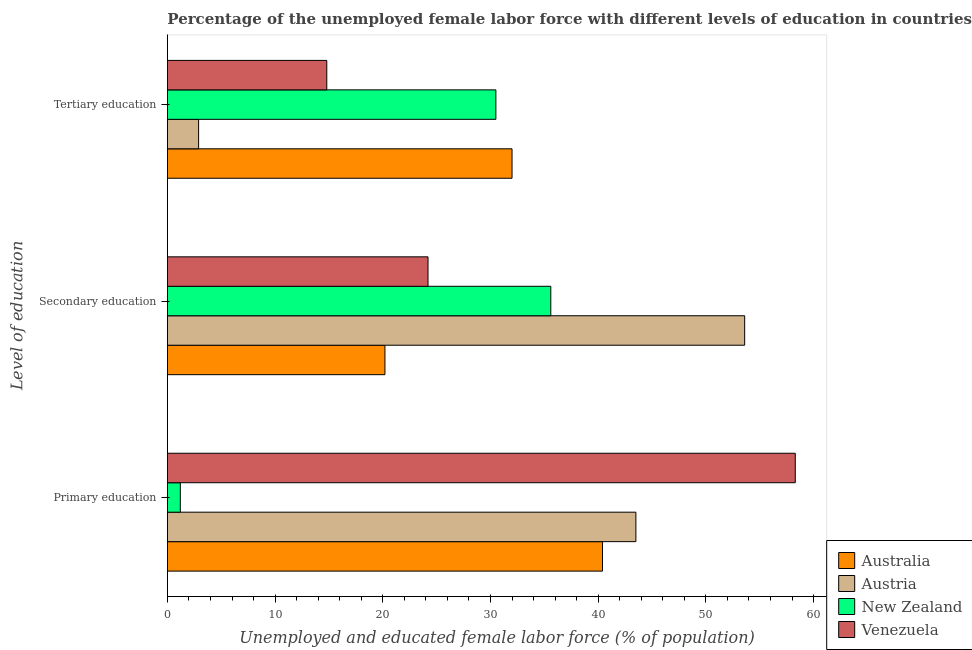How many bars are there on the 1st tick from the top?
Your answer should be very brief. 4. What is the percentage of female labor force who received tertiary education in Venezuela?
Your answer should be very brief. 14.8. Across all countries, what is the maximum percentage of female labor force who received tertiary education?
Ensure brevity in your answer.  32. Across all countries, what is the minimum percentage of female labor force who received primary education?
Offer a very short reply. 1.2. In which country was the percentage of female labor force who received primary education maximum?
Keep it short and to the point. Venezuela. In which country was the percentage of female labor force who received tertiary education minimum?
Your answer should be compact. Austria. What is the total percentage of female labor force who received primary education in the graph?
Give a very brief answer. 143.4. What is the difference between the percentage of female labor force who received tertiary education in Venezuela and that in Austria?
Provide a succinct answer. 11.9. What is the difference between the percentage of female labor force who received primary education in New Zealand and the percentage of female labor force who received tertiary education in Austria?
Make the answer very short. -1.7. What is the average percentage of female labor force who received primary education per country?
Provide a short and direct response. 35.85. What is the difference between the percentage of female labor force who received secondary education and percentage of female labor force who received tertiary education in New Zealand?
Your answer should be compact. 5.1. What is the ratio of the percentage of female labor force who received primary education in Australia to that in New Zealand?
Ensure brevity in your answer.  33.67. Is the difference between the percentage of female labor force who received tertiary education in Australia and New Zealand greater than the difference between the percentage of female labor force who received secondary education in Australia and New Zealand?
Your answer should be compact. Yes. What is the difference between the highest and the lowest percentage of female labor force who received secondary education?
Provide a succinct answer. 33.4. In how many countries, is the percentage of female labor force who received secondary education greater than the average percentage of female labor force who received secondary education taken over all countries?
Keep it short and to the point. 2. What does the 3rd bar from the top in Secondary education represents?
Ensure brevity in your answer.  Austria. What does the 3rd bar from the bottom in Tertiary education represents?
Ensure brevity in your answer.  New Zealand. How many countries are there in the graph?
Provide a succinct answer. 4. What is the difference between two consecutive major ticks on the X-axis?
Make the answer very short. 10. Are the values on the major ticks of X-axis written in scientific E-notation?
Provide a short and direct response. No. Does the graph contain any zero values?
Your answer should be very brief. No. Does the graph contain grids?
Your response must be concise. No. What is the title of the graph?
Offer a very short reply. Percentage of the unemployed female labor force with different levels of education in countries. What is the label or title of the X-axis?
Your answer should be compact. Unemployed and educated female labor force (% of population). What is the label or title of the Y-axis?
Your response must be concise. Level of education. What is the Unemployed and educated female labor force (% of population) in Australia in Primary education?
Give a very brief answer. 40.4. What is the Unemployed and educated female labor force (% of population) in Austria in Primary education?
Your response must be concise. 43.5. What is the Unemployed and educated female labor force (% of population) in New Zealand in Primary education?
Offer a very short reply. 1.2. What is the Unemployed and educated female labor force (% of population) of Venezuela in Primary education?
Keep it short and to the point. 58.3. What is the Unemployed and educated female labor force (% of population) of Australia in Secondary education?
Your answer should be very brief. 20.2. What is the Unemployed and educated female labor force (% of population) of Austria in Secondary education?
Offer a terse response. 53.6. What is the Unemployed and educated female labor force (% of population) of New Zealand in Secondary education?
Offer a very short reply. 35.6. What is the Unemployed and educated female labor force (% of population) of Venezuela in Secondary education?
Ensure brevity in your answer.  24.2. What is the Unemployed and educated female labor force (% of population) in Australia in Tertiary education?
Ensure brevity in your answer.  32. What is the Unemployed and educated female labor force (% of population) in Austria in Tertiary education?
Offer a terse response. 2.9. What is the Unemployed and educated female labor force (% of population) in New Zealand in Tertiary education?
Your response must be concise. 30.5. What is the Unemployed and educated female labor force (% of population) of Venezuela in Tertiary education?
Provide a short and direct response. 14.8. Across all Level of education, what is the maximum Unemployed and educated female labor force (% of population) of Australia?
Offer a terse response. 40.4. Across all Level of education, what is the maximum Unemployed and educated female labor force (% of population) in Austria?
Ensure brevity in your answer.  53.6. Across all Level of education, what is the maximum Unemployed and educated female labor force (% of population) in New Zealand?
Ensure brevity in your answer.  35.6. Across all Level of education, what is the maximum Unemployed and educated female labor force (% of population) in Venezuela?
Keep it short and to the point. 58.3. Across all Level of education, what is the minimum Unemployed and educated female labor force (% of population) of Australia?
Provide a short and direct response. 20.2. Across all Level of education, what is the minimum Unemployed and educated female labor force (% of population) of Austria?
Offer a terse response. 2.9. Across all Level of education, what is the minimum Unemployed and educated female labor force (% of population) in New Zealand?
Your answer should be very brief. 1.2. Across all Level of education, what is the minimum Unemployed and educated female labor force (% of population) in Venezuela?
Provide a short and direct response. 14.8. What is the total Unemployed and educated female labor force (% of population) in Australia in the graph?
Your response must be concise. 92.6. What is the total Unemployed and educated female labor force (% of population) of Austria in the graph?
Provide a succinct answer. 100. What is the total Unemployed and educated female labor force (% of population) in New Zealand in the graph?
Your response must be concise. 67.3. What is the total Unemployed and educated female labor force (% of population) in Venezuela in the graph?
Give a very brief answer. 97.3. What is the difference between the Unemployed and educated female labor force (% of population) of Australia in Primary education and that in Secondary education?
Your answer should be very brief. 20.2. What is the difference between the Unemployed and educated female labor force (% of population) in New Zealand in Primary education and that in Secondary education?
Make the answer very short. -34.4. What is the difference between the Unemployed and educated female labor force (% of population) of Venezuela in Primary education and that in Secondary education?
Keep it short and to the point. 34.1. What is the difference between the Unemployed and educated female labor force (% of population) in Austria in Primary education and that in Tertiary education?
Give a very brief answer. 40.6. What is the difference between the Unemployed and educated female labor force (% of population) of New Zealand in Primary education and that in Tertiary education?
Make the answer very short. -29.3. What is the difference between the Unemployed and educated female labor force (% of population) in Venezuela in Primary education and that in Tertiary education?
Offer a terse response. 43.5. What is the difference between the Unemployed and educated female labor force (% of population) of Australia in Secondary education and that in Tertiary education?
Make the answer very short. -11.8. What is the difference between the Unemployed and educated female labor force (% of population) in Austria in Secondary education and that in Tertiary education?
Provide a short and direct response. 50.7. What is the difference between the Unemployed and educated female labor force (% of population) in New Zealand in Secondary education and that in Tertiary education?
Ensure brevity in your answer.  5.1. What is the difference between the Unemployed and educated female labor force (% of population) of Venezuela in Secondary education and that in Tertiary education?
Your response must be concise. 9.4. What is the difference between the Unemployed and educated female labor force (% of population) in Australia in Primary education and the Unemployed and educated female labor force (% of population) in New Zealand in Secondary education?
Offer a terse response. 4.8. What is the difference between the Unemployed and educated female labor force (% of population) in Austria in Primary education and the Unemployed and educated female labor force (% of population) in New Zealand in Secondary education?
Make the answer very short. 7.9. What is the difference between the Unemployed and educated female labor force (% of population) in Austria in Primary education and the Unemployed and educated female labor force (% of population) in Venezuela in Secondary education?
Offer a very short reply. 19.3. What is the difference between the Unemployed and educated female labor force (% of population) of Australia in Primary education and the Unemployed and educated female labor force (% of population) of Austria in Tertiary education?
Give a very brief answer. 37.5. What is the difference between the Unemployed and educated female labor force (% of population) in Australia in Primary education and the Unemployed and educated female labor force (% of population) in New Zealand in Tertiary education?
Your answer should be very brief. 9.9. What is the difference between the Unemployed and educated female labor force (% of population) of Australia in Primary education and the Unemployed and educated female labor force (% of population) of Venezuela in Tertiary education?
Provide a short and direct response. 25.6. What is the difference between the Unemployed and educated female labor force (% of population) in Austria in Primary education and the Unemployed and educated female labor force (% of population) in New Zealand in Tertiary education?
Ensure brevity in your answer.  13. What is the difference between the Unemployed and educated female labor force (% of population) of Austria in Primary education and the Unemployed and educated female labor force (% of population) of Venezuela in Tertiary education?
Your answer should be compact. 28.7. What is the difference between the Unemployed and educated female labor force (% of population) in New Zealand in Primary education and the Unemployed and educated female labor force (% of population) in Venezuela in Tertiary education?
Provide a short and direct response. -13.6. What is the difference between the Unemployed and educated female labor force (% of population) of Austria in Secondary education and the Unemployed and educated female labor force (% of population) of New Zealand in Tertiary education?
Offer a very short reply. 23.1. What is the difference between the Unemployed and educated female labor force (% of population) in Austria in Secondary education and the Unemployed and educated female labor force (% of population) in Venezuela in Tertiary education?
Give a very brief answer. 38.8. What is the difference between the Unemployed and educated female labor force (% of population) of New Zealand in Secondary education and the Unemployed and educated female labor force (% of population) of Venezuela in Tertiary education?
Your answer should be very brief. 20.8. What is the average Unemployed and educated female labor force (% of population) of Australia per Level of education?
Ensure brevity in your answer.  30.87. What is the average Unemployed and educated female labor force (% of population) in Austria per Level of education?
Keep it short and to the point. 33.33. What is the average Unemployed and educated female labor force (% of population) in New Zealand per Level of education?
Provide a short and direct response. 22.43. What is the average Unemployed and educated female labor force (% of population) in Venezuela per Level of education?
Offer a very short reply. 32.43. What is the difference between the Unemployed and educated female labor force (% of population) in Australia and Unemployed and educated female labor force (% of population) in Austria in Primary education?
Give a very brief answer. -3.1. What is the difference between the Unemployed and educated female labor force (% of population) of Australia and Unemployed and educated female labor force (% of population) of New Zealand in Primary education?
Ensure brevity in your answer.  39.2. What is the difference between the Unemployed and educated female labor force (% of population) in Australia and Unemployed and educated female labor force (% of population) in Venezuela in Primary education?
Give a very brief answer. -17.9. What is the difference between the Unemployed and educated female labor force (% of population) of Austria and Unemployed and educated female labor force (% of population) of New Zealand in Primary education?
Provide a succinct answer. 42.3. What is the difference between the Unemployed and educated female labor force (% of population) of Austria and Unemployed and educated female labor force (% of population) of Venezuela in Primary education?
Offer a very short reply. -14.8. What is the difference between the Unemployed and educated female labor force (% of population) of New Zealand and Unemployed and educated female labor force (% of population) of Venezuela in Primary education?
Your response must be concise. -57.1. What is the difference between the Unemployed and educated female labor force (% of population) of Australia and Unemployed and educated female labor force (% of population) of Austria in Secondary education?
Offer a very short reply. -33.4. What is the difference between the Unemployed and educated female labor force (% of population) in Australia and Unemployed and educated female labor force (% of population) in New Zealand in Secondary education?
Offer a terse response. -15.4. What is the difference between the Unemployed and educated female labor force (% of population) in Australia and Unemployed and educated female labor force (% of population) in Venezuela in Secondary education?
Offer a very short reply. -4. What is the difference between the Unemployed and educated female labor force (% of population) in Austria and Unemployed and educated female labor force (% of population) in New Zealand in Secondary education?
Offer a very short reply. 18. What is the difference between the Unemployed and educated female labor force (% of population) of Austria and Unemployed and educated female labor force (% of population) of Venezuela in Secondary education?
Provide a short and direct response. 29.4. What is the difference between the Unemployed and educated female labor force (% of population) of Australia and Unemployed and educated female labor force (% of population) of Austria in Tertiary education?
Keep it short and to the point. 29.1. What is the difference between the Unemployed and educated female labor force (% of population) of Austria and Unemployed and educated female labor force (% of population) of New Zealand in Tertiary education?
Your response must be concise. -27.6. What is the difference between the Unemployed and educated female labor force (% of population) in Austria and Unemployed and educated female labor force (% of population) in Venezuela in Tertiary education?
Your answer should be compact. -11.9. What is the ratio of the Unemployed and educated female labor force (% of population) of Australia in Primary education to that in Secondary education?
Offer a terse response. 2. What is the ratio of the Unemployed and educated female labor force (% of population) of Austria in Primary education to that in Secondary education?
Ensure brevity in your answer.  0.81. What is the ratio of the Unemployed and educated female labor force (% of population) of New Zealand in Primary education to that in Secondary education?
Offer a terse response. 0.03. What is the ratio of the Unemployed and educated female labor force (% of population) in Venezuela in Primary education to that in Secondary education?
Ensure brevity in your answer.  2.41. What is the ratio of the Unemployed and educated female labor force (% of population) of Australia in Primary education to that in Tertiary education?
Ensure brevity in your answer.  1.26. What is the ratio of the Unemployed and educated female labor force (% of population) in New Zealand in Primary education to that in Tertiary education?
Your answer should be compact. 0.04. What is the ratio of the Unemployed and educated female labor force (% of population) in Venezuela in Primary education to that in Tertiary education?
Ensure brevity in your answer.  3.94. What is the ratio of the Unemployed and educated female labor force (% of population) in Australia in Secondary education to that in Tertiary education?
Keep it short and to the point. 0.63. What is the ratio of the Unemployed and educated female labor force (% of population) in Austria in Secondary education to that in Tertiary education?
Provide a succinct answer. 18.48. What is the ratio of the Unemployed and educated female labor force (% of population) of New Zealand in Secondary education to that in Tertiary education?
Your response must be concise. 1.17. What is the ratio of the Unemployed and educated female labor force (% of population) of Venezuela in Secondary education to that in Tertiary education?
Offer a terse response. 1.64. What is the difference between the highest and the second highest Unemployed and educated female labor force (% of population) in Austria?
Give a very brief answer. 10.1. What is the difference between the highest and the second highest Unemployed and educated female labor force (% of population) of Venezuela?
Offer a very short reply. 34.1. What is the difference between the highest and the lowest Unemployed and educated female labor force (% of population) of Australia?
Ensure brevity in your answer.  20.2. What is the difference between the highest and the lowest Unemployed and educated female labor force (% of population) in Austria?
Provide a succinct answer. 50.7. What is the difference between the highest and the lowest Unemployed and educated female labor force (% of population) in New Zealand?
Make the answer very short. 34.4. What is the difference between the highest and the lowest Unemployed and educated female labor force (% of population) of Venezuela?
Provide a short and direct response. 43.5. 